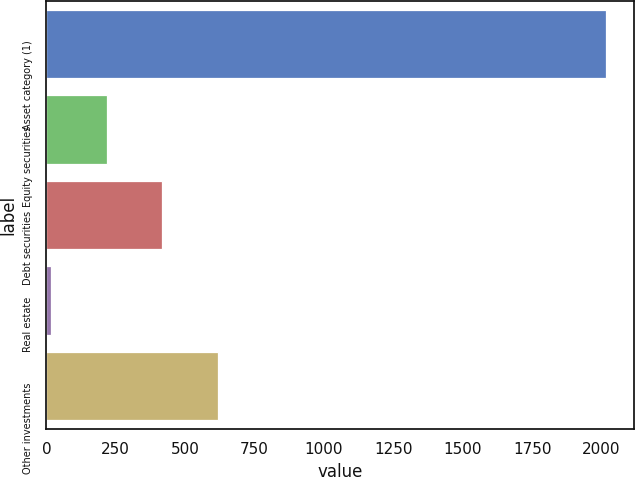Convert chart to OTSL. <chart><loc_0><loc_0><loc_500><loc_500><bar_chart><fcel>Asset category (1)<fcel>Equity securities<fcel>Debt securities<fcel>Real estate<fcel>Other investments<nl><fcel>2017<fcel>217.9<fcel>417.8<fcel>18<fcel>617.7<nl></chart> 